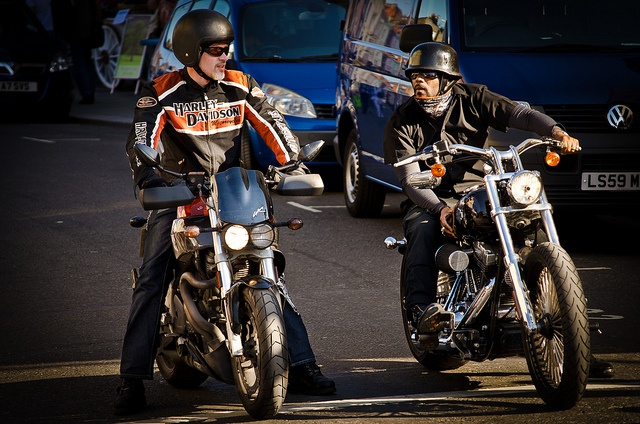Describe the objects in this image and their specific colors. I can see car in black, gray, navy, and maroon tones, motorcycle in black, ivory, gray, and maroon tones, motorcycle in black, gray, maroon, and white tones, people in black, white, maroon, and gray tones, and people in black, gray, and maroon tones in this image. 